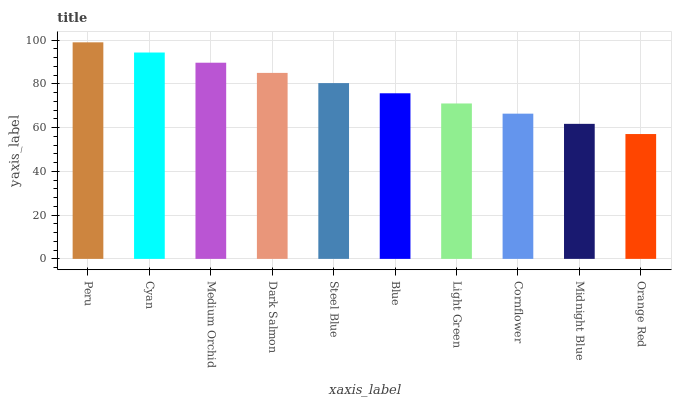Is Orange Red the minimum?
Answer yes or no. Yes. Is Peru the maximum?
Answer yes or no. Yes. Is Cyan the minimum?
Answer yes or no. No. Is Cyan the maximum?
Answer yes or no. No. Is Peru greater than Cyan?
Answer yes or no. Yes. Is Cyan less than Peru?
Answer yes or no. Yes. Is Cyan greater than Peru?
Answer yes or no. No. Is Peru less than Cyan?
Answer yes or no. No. Is Steel Blue the high median?
Answer yes or no. Yes. Is Blue the low median?
Answer yes or no. Yes. Is Cyan the high median?
Answer yes or no. No. Is Medium Orchid the low median?
Answer yes or no. No. 